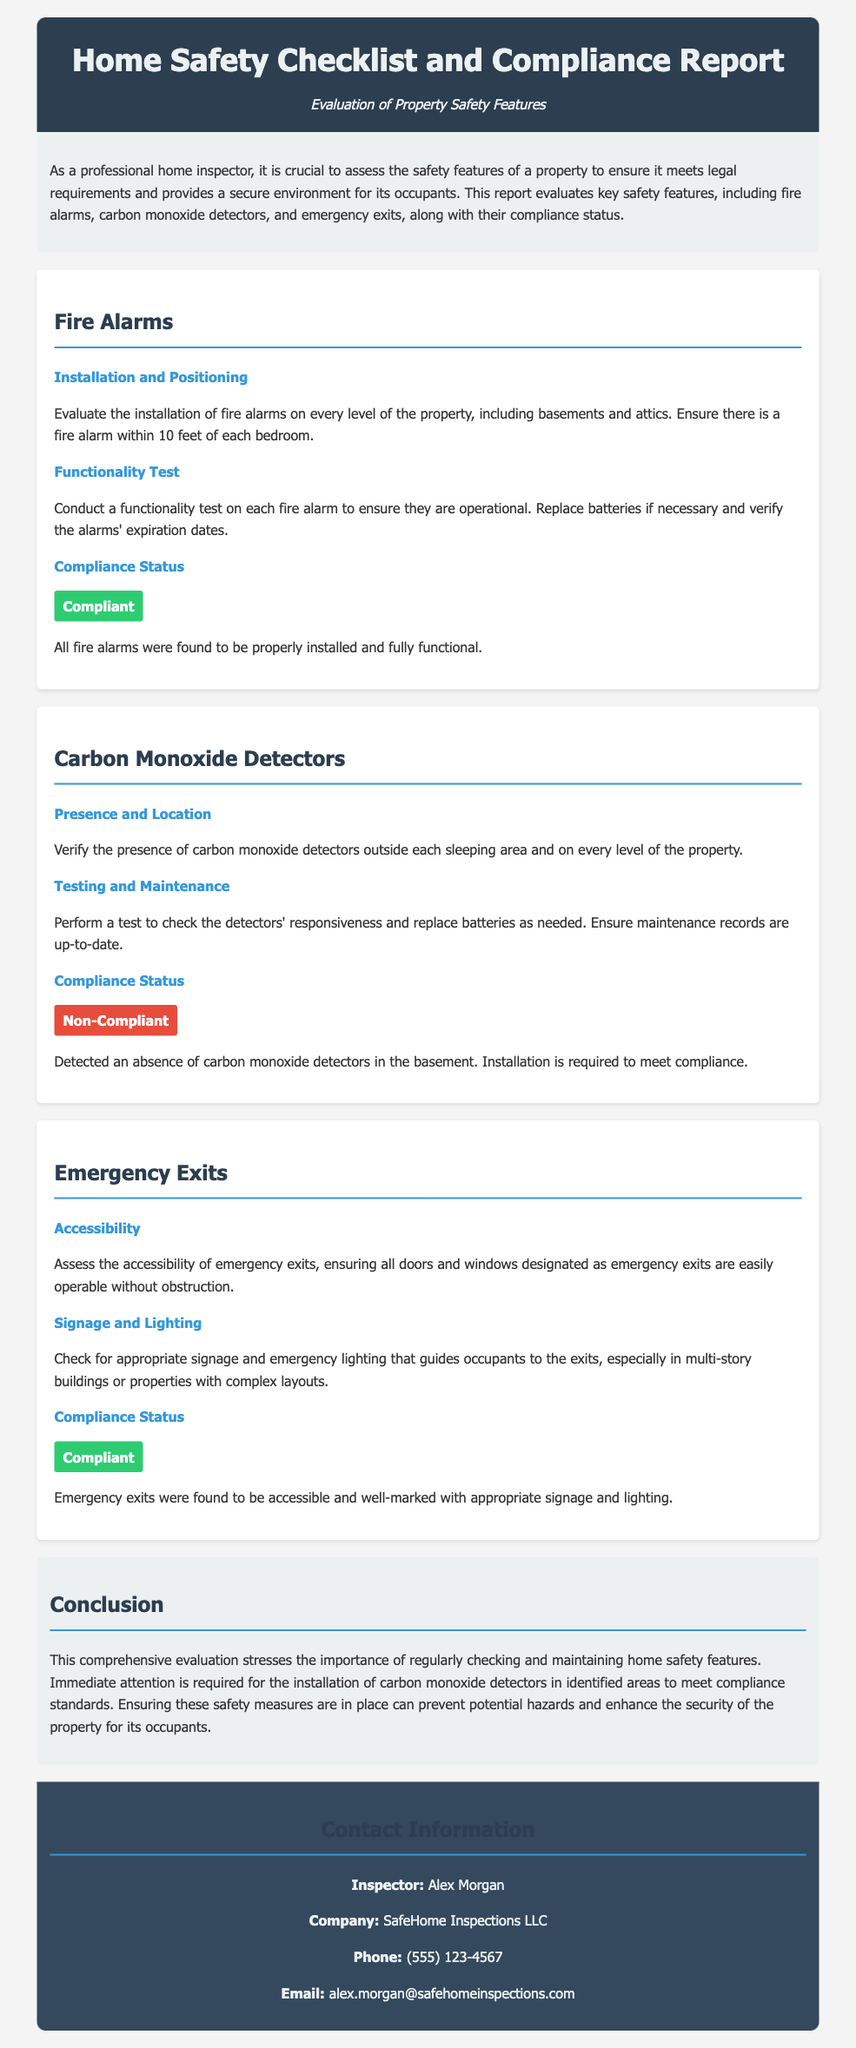what is the title of the document? The title of the document is presented as the main heading in the header section.
Answer: Home Safety Checklist and Compliance Report who is the inspector mentioned in the report? The inspector's name is provided in the contact information section of the document.
Answer: Alex Morgan what is the compliance status of fire alarms? The compliance status is stated under the fire alarms section, indicating whether they are compliant or non-compliant.
Answer: Compliant how many levels should fire alarms be installed on? The document specifies the requirement for fire alarms in relation to property levels.
Answer: Every level are carbon monoxide detectors present in the basement? The presence of carbon monoxide detectors is evaluated, and their status is mentioned.
Answer: No what is the status of emergency exits according to the report? The compliance status of emergency exits is clearly articulated in their respective section.
Answer: Compliant what does the evaluation emphasize in the conclusion? The conclusion summarizes the importance of monitoring certain safety features and necessary actions.
Answer: Regularly checking and maintaining how can the contact information be found? The contact information section is specifically designated to display relevant details about the inspector.
Answer: At the bottom of the report 